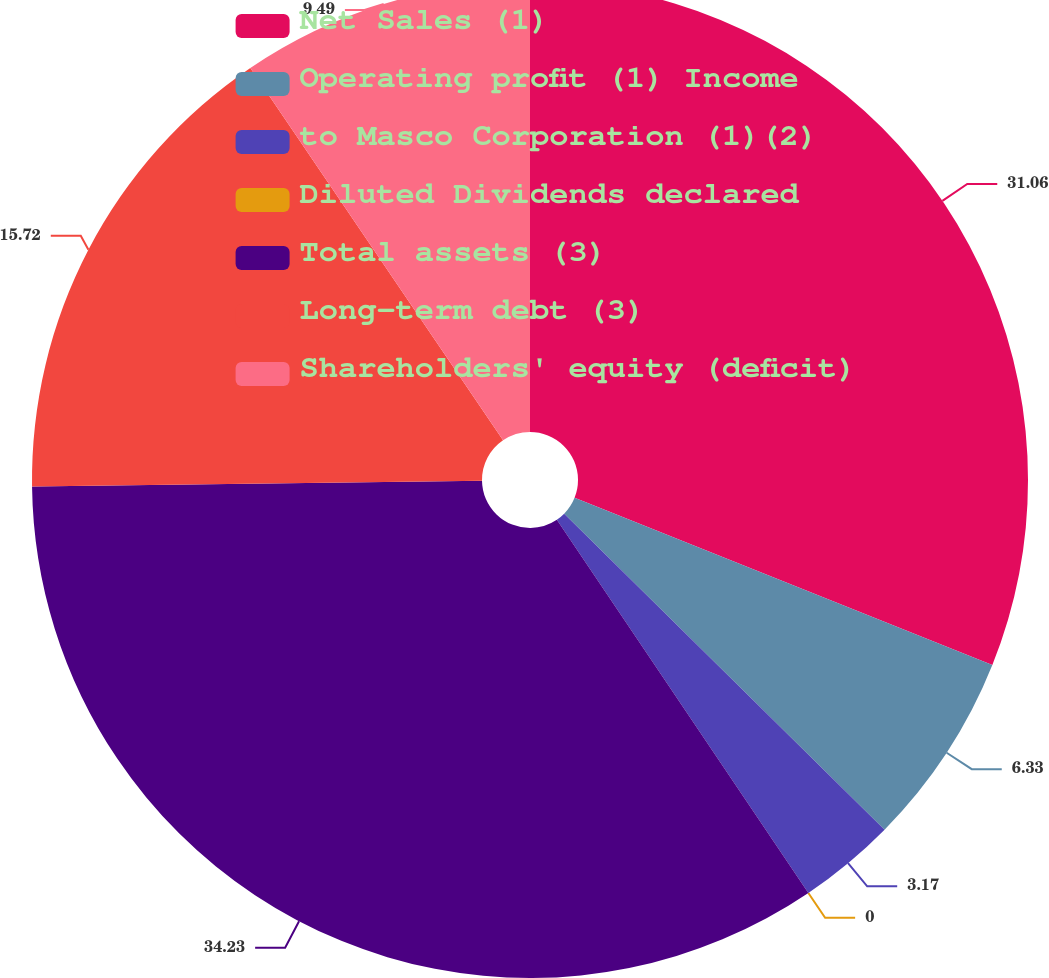Convert chart. <chart><loc_0><loc_0><loc_500><loc_500><pie_chart><fcel>Net Sales (1)<fcel>Operating profit (1) Income<fcel>to Masco Corporation (1)(2)<fcel>Diluted Dividends declared<fcel>Total assets (3)<fcel>Long-term debt (3)<fcel>Shareholders' equity (deficit)<nl><fcel>31.06%<fcel>6.33%<fcel>3.17%<fcel>0.0%<fcel>34.23%<fcel>15.72%<fcel>9.49%<nl></chart> 